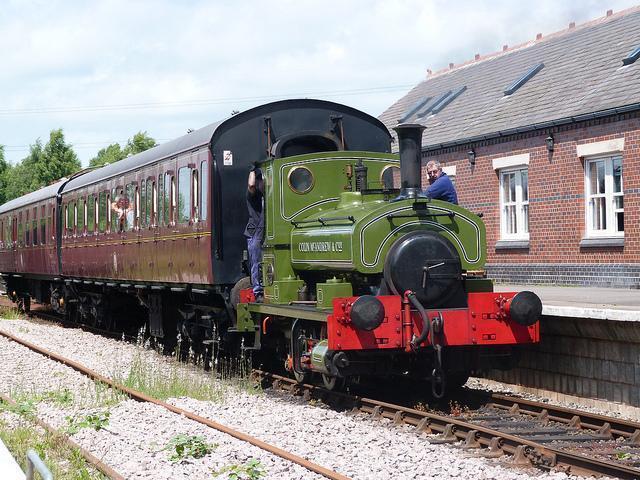What years was this machine first introduced?
Indicate the correct response by choosing from the four available options to answer the question.
Options: 1866, 2004, 1994, 1804. 1804. 